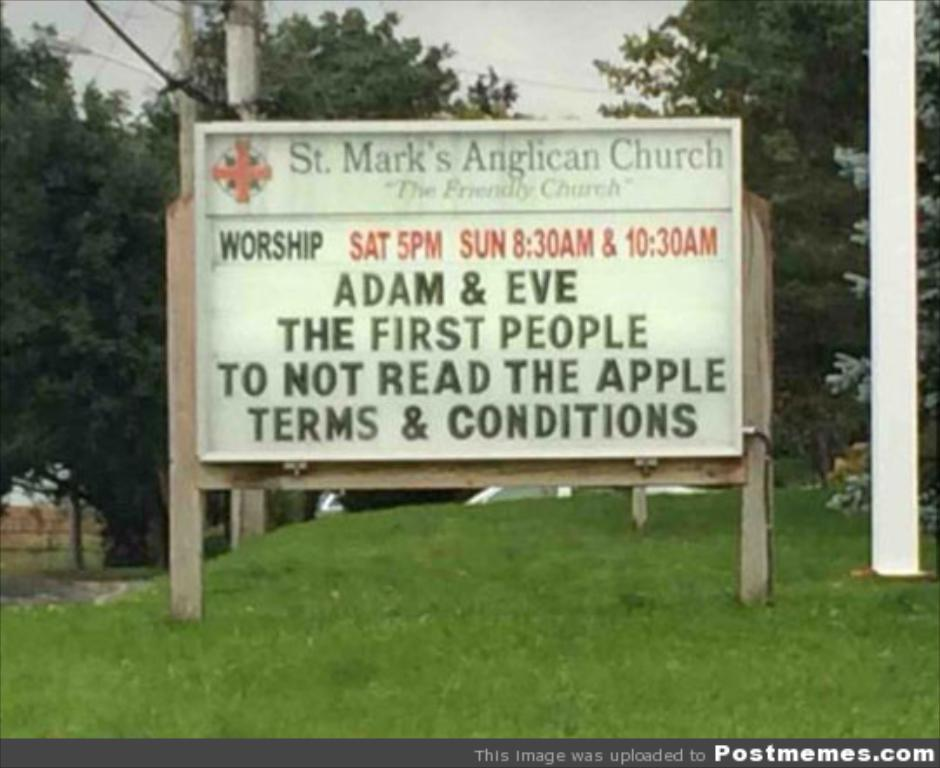What is the main structure in the image? There is a board on wooden poles in the image. What type of terrain is visible in the image? There is grass visible in the image. How many wooden poles can be seen in the image? There are poles in the image. What other natural elements are present in the image? There are trees in the image. What can be seen in the background of the image? The sky is visible in the background of the image. Where is the text located in the image? The text is in the bottom right side of the image. What type of force is being applied to the drum in the image? There is no drum present in the image. What is the tendency of the grass in the image? The grass in the image does not have a tendency, as it is a static image. 